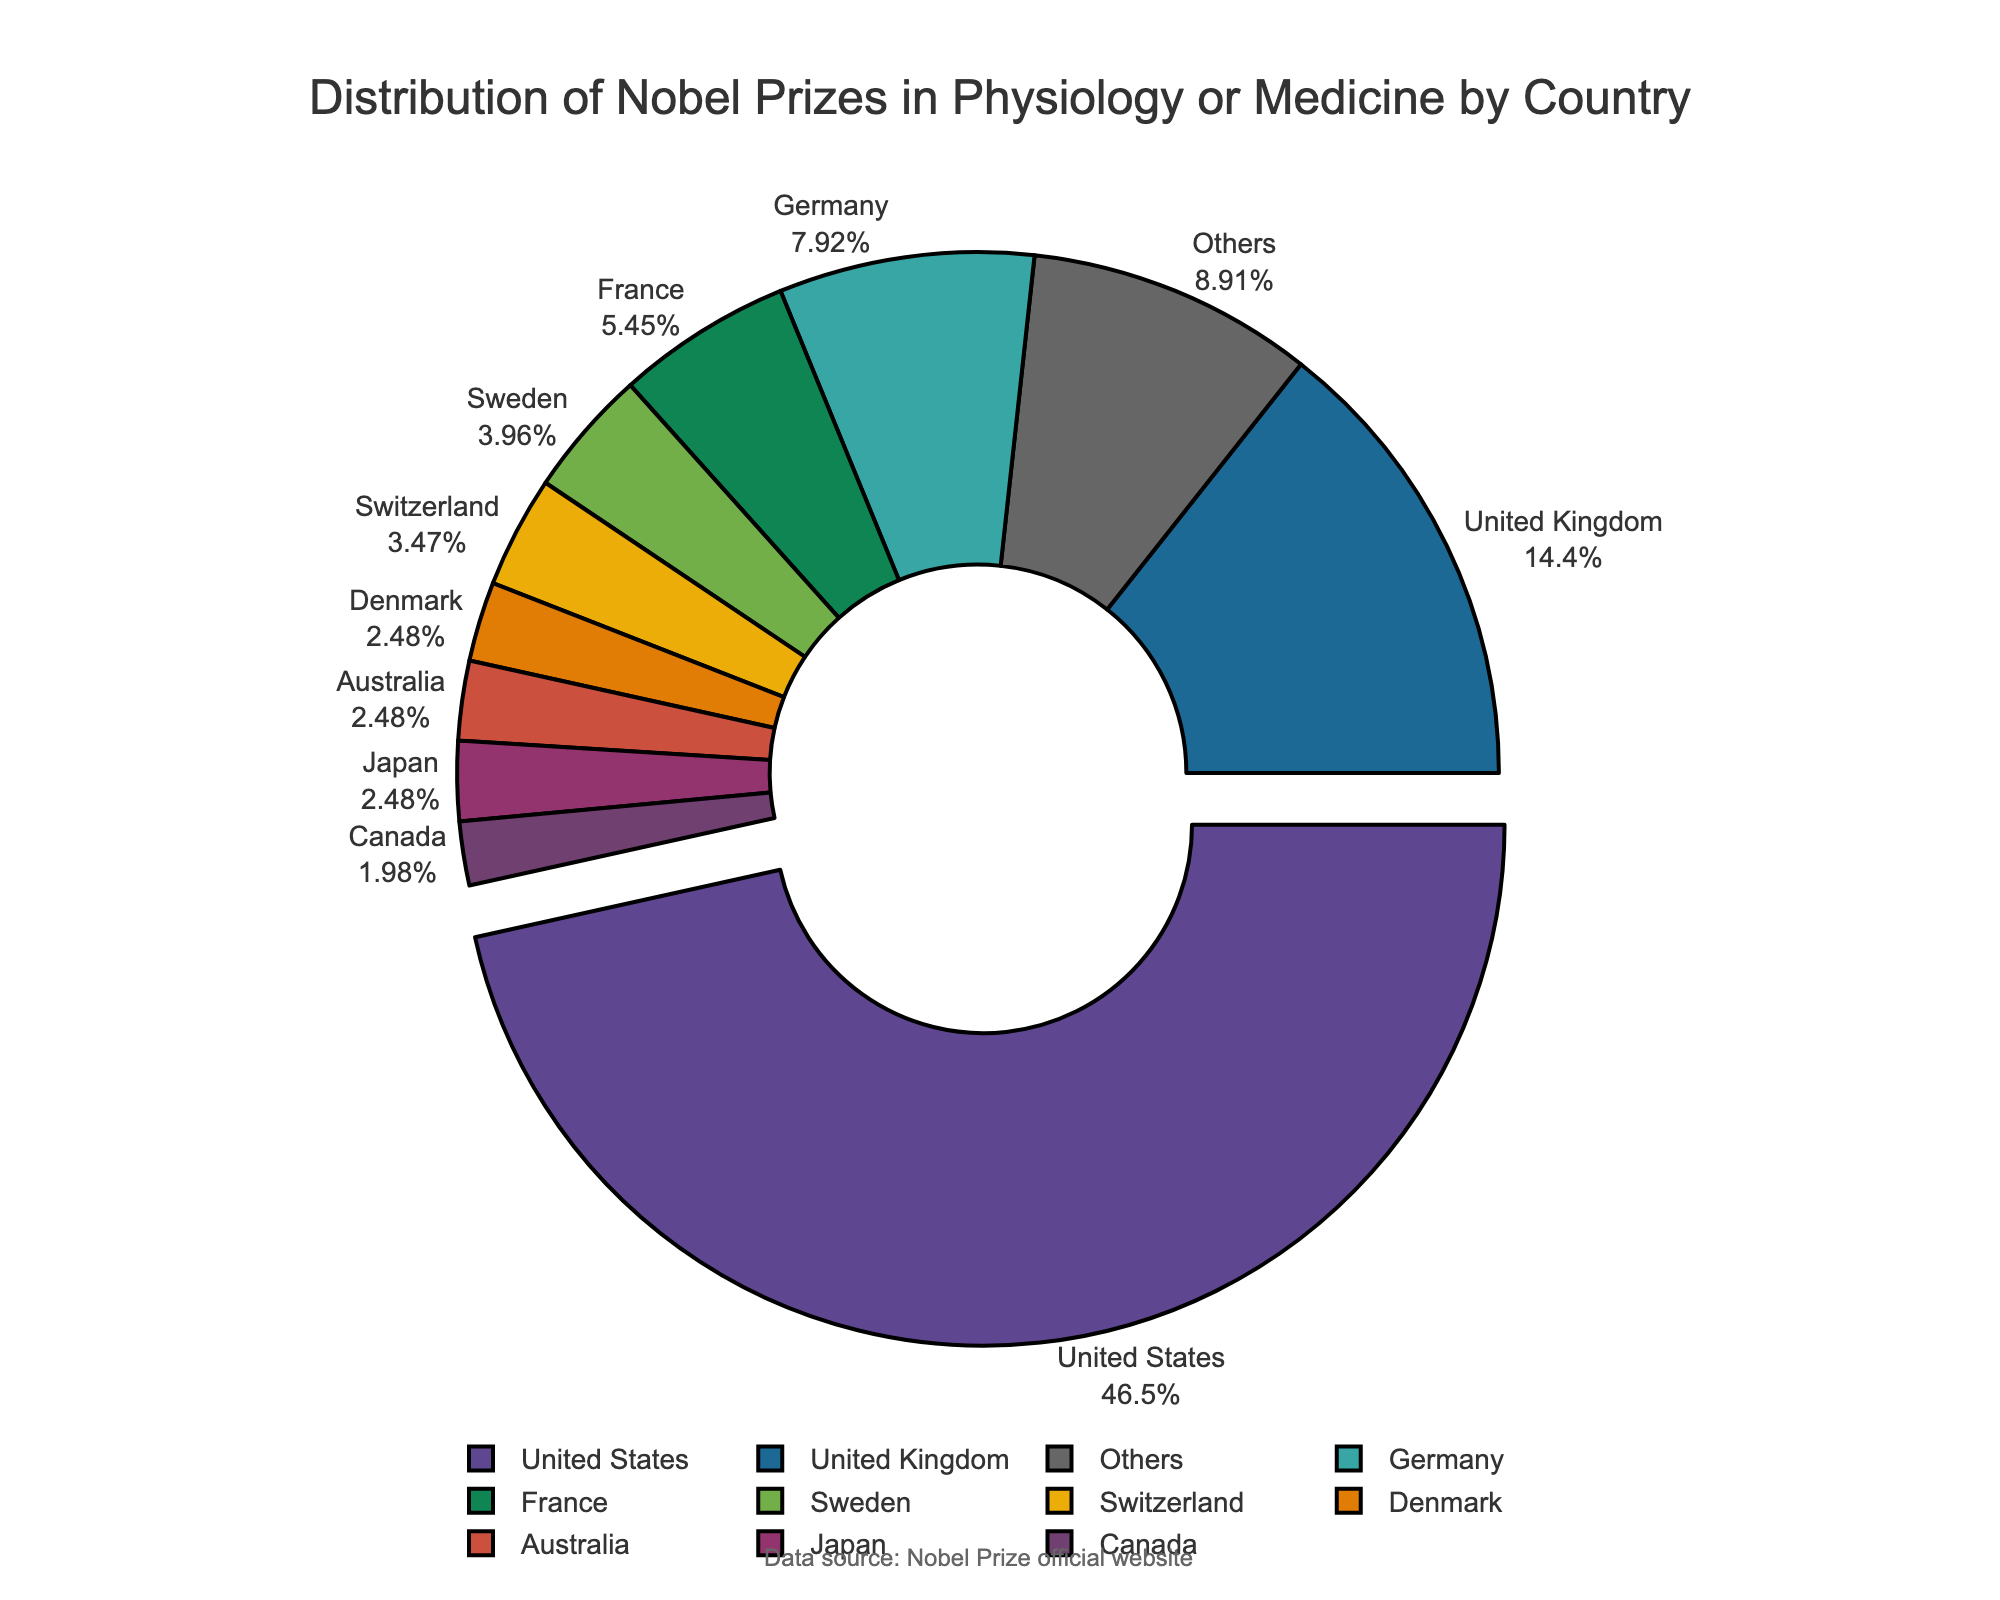Which country has the highest number of Nobel Prizes in Physiology or Medicine? The pie chart shows that the United States has the largest section of the pie, indicating it has the highest number of Nobel Prizes in Physiology or Medicine.
Answer: United States What is the combined number of Nobel Prizes for the United Kingdom and Germany? The United Kingdom has 29 prizes, and Germany has 16. Adding these together, 29 + 16 = 45.
Answer: 45 How many countries are included in the "Others" category? The pie chart lists individual countries and then one section as "Others". The top 10 countries are shown explicitly. Subtracting these from the total 20, "Others" includes the remaining 10 countries.
Answer: 10 Which country has more Nobel Prizes in Physiology or Medicine, Sweden or Switzerland? Looking at the chart, Sweden has 8 prizes while Switzerland has 7.
Answer: Sweden Does Australia or Japan have a greater share of Nobel Prizes in Physiology or Medicine? The pie chart shows that both Australia and Japan have the same number of prizes, 5 each, so they have an equal share.
Answer: Equal By what percentage does the United States' number of Nobel Prizes exceed that of the United Kingdom? The United States has 94 prizes and the United Kingdom has 29. The difference is 94 - 29 = 65. To find the percentage, (65 / 29) * 100 ≈ 224.14%.
Answer: ≈ 224.14% What is the percentage of Nobel Prizes in Physiology or Medicine held by the "Others" category? The pie chart shows the percentage visually; "Others" comprises one of the sections of the pie chart. Its percentage is explicitly stated on the chart as one of the labels.
Answer: 7.04% What is the ratio of the number of prizes between France and Canada? France has 11 prizes and Canada has 4. The ratio is 11:4.
Answer: 11:4 What is the total number of Nobel Prizes in Physiology or Medicine awarded to top 10 countries combined? Sum the number of prizes for the top 10 countries: 94 (US) + 29 (UK) + 16 (Germany) + 11 (France) + 8 (Sweden) + 7 (Switzerland) + 5 (Denmark) + 5 (Australia) + 5 (Japan) + 4 (Canada) = 184.
Answer: 184 